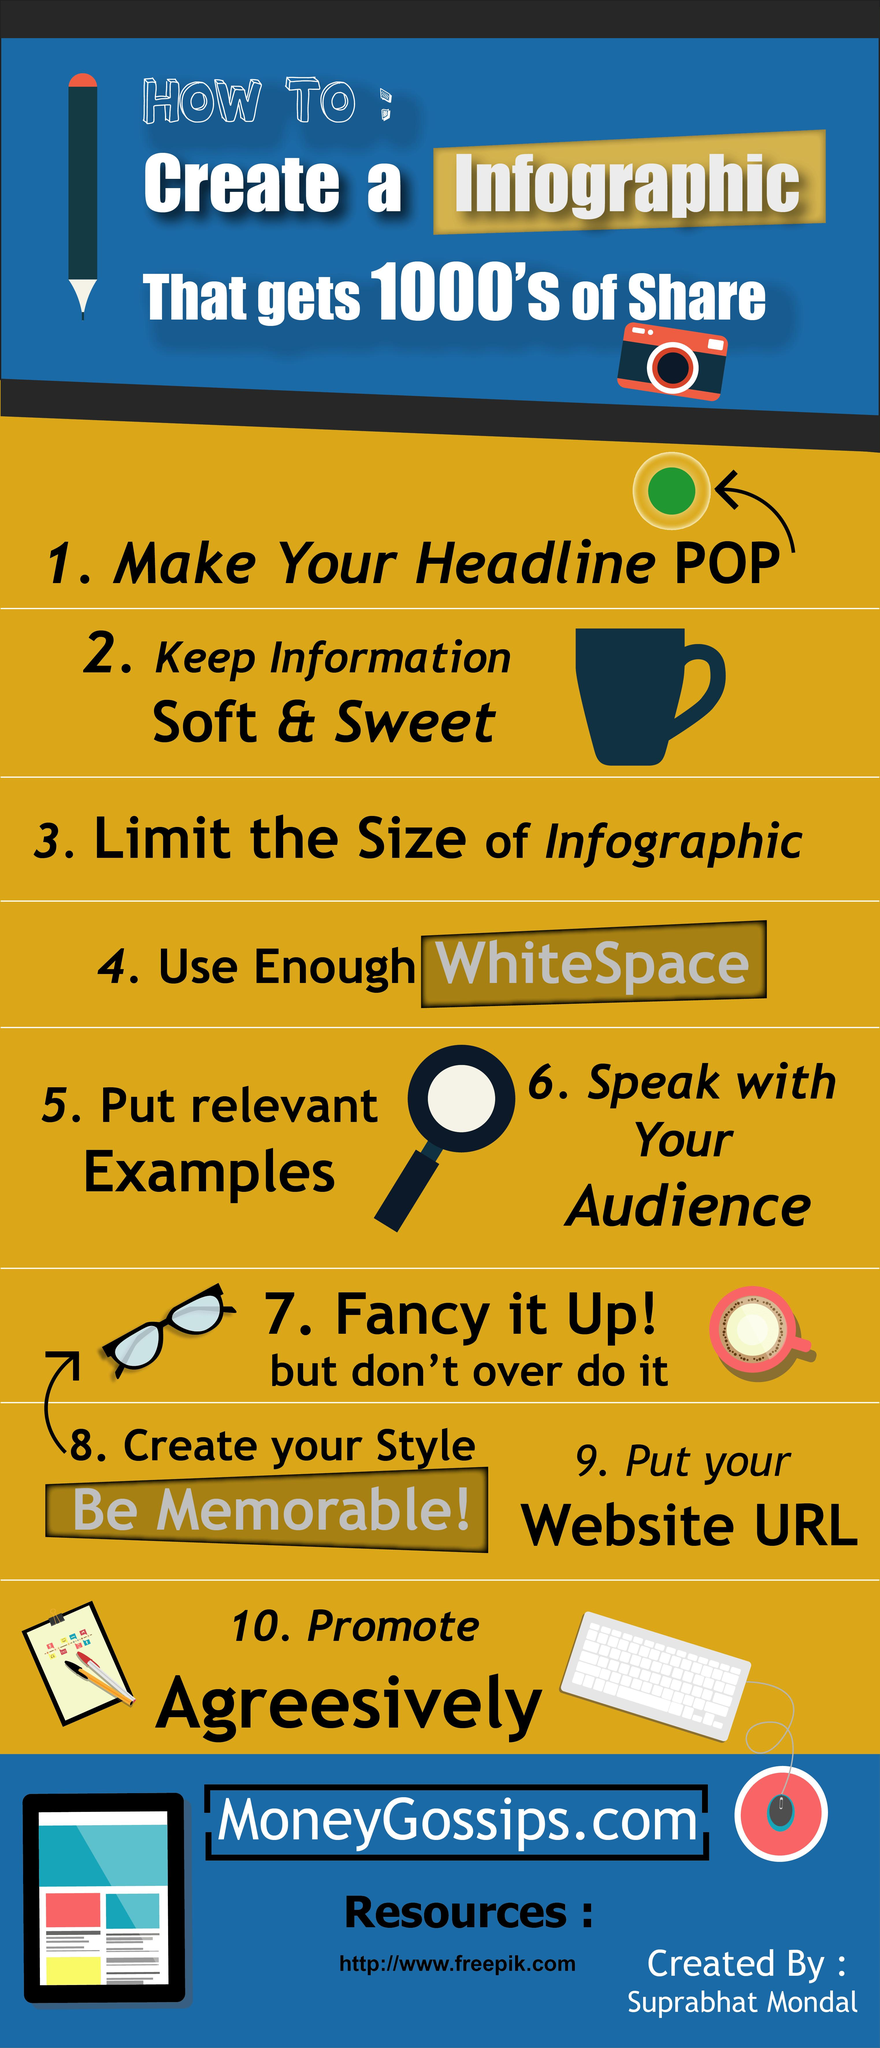Give some essential details in this illustration. The color of the cup shown in the infographic is blue. 